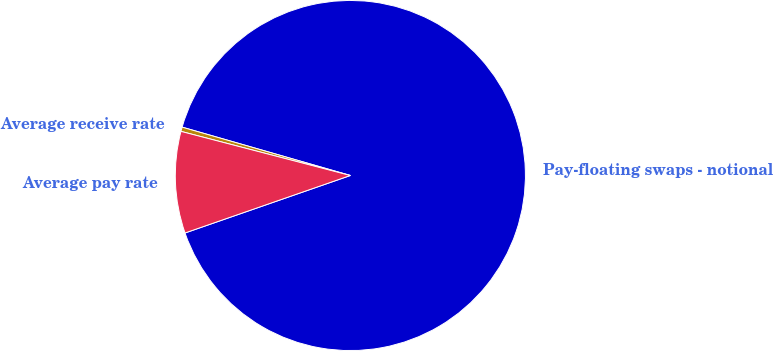Convert chart. <chart><loc_0><loc_0><loc_500><loc_500><pie_chart><fcel>Pay-floating swaps - notional<fcel>Average receive rate<fcel>Average pay rate<nl><fcel>90.22%<fcel>0.4%<fcel>9.38%<nl></chart> 